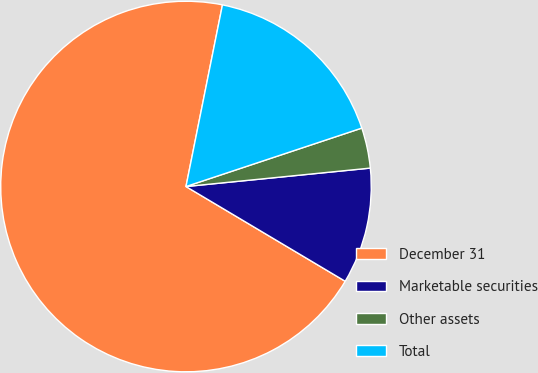Convert chart to OTSL. <chart><loc_0><loc_0><loc_500><loc_500><pie_chart><fcel>December 31<fcel>Marketable securities<fcel>Other assets<fcel>Total<nl><fcel>69.61%<fcel>10.13%<fcel>3.52%<fcel>16.74%<nl></chart> 